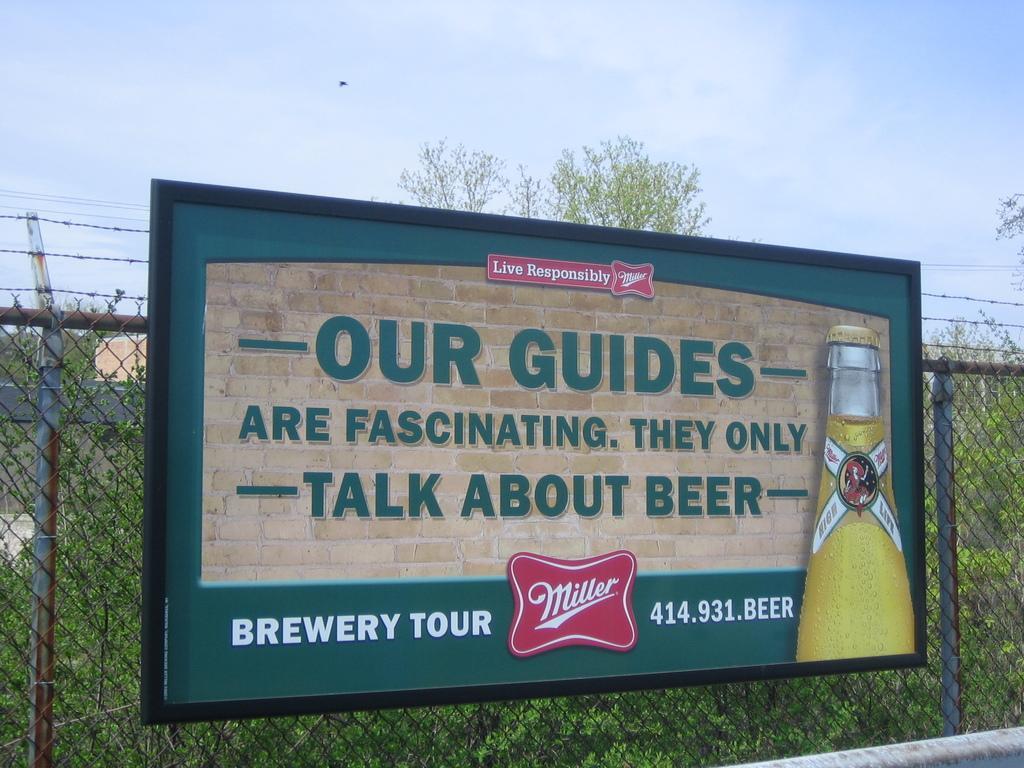How would you summarize this image in a sentence or two? On this mask there is a hoarding. Backside of this mesh there are plants. Sky is cloudy. 